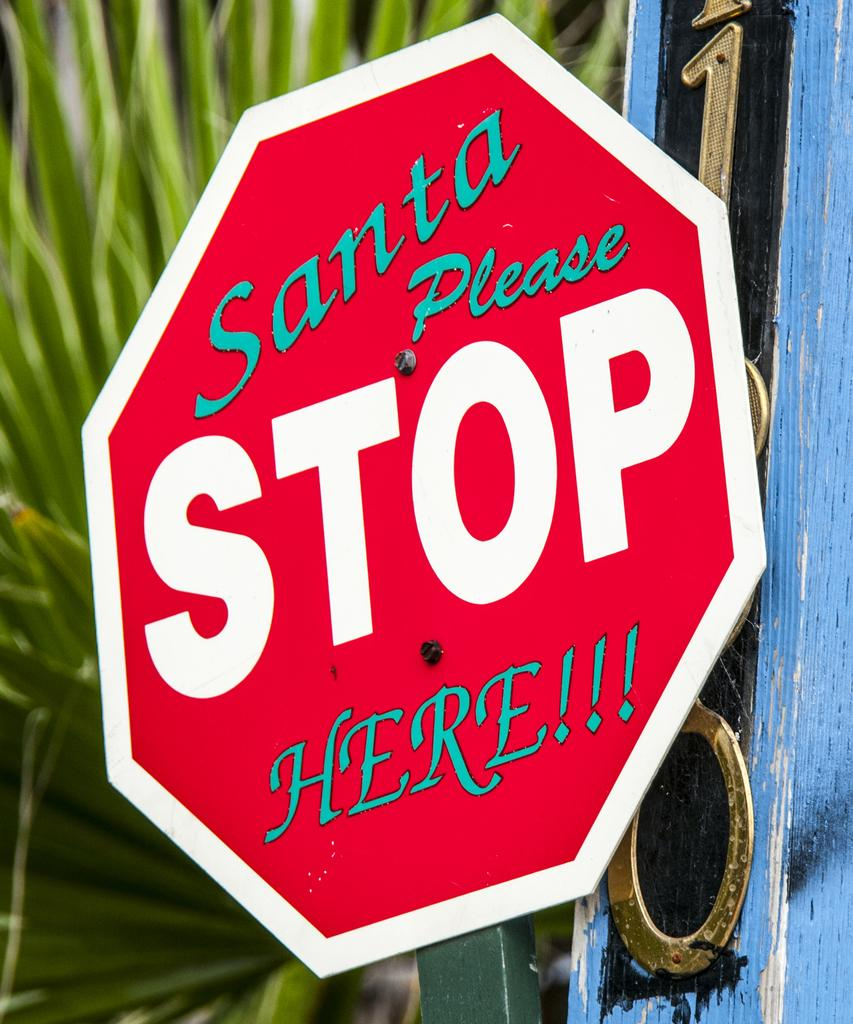<image>
Create a compact narrative representing the image presented. a Stop Here Santa sign that was edited that way. 